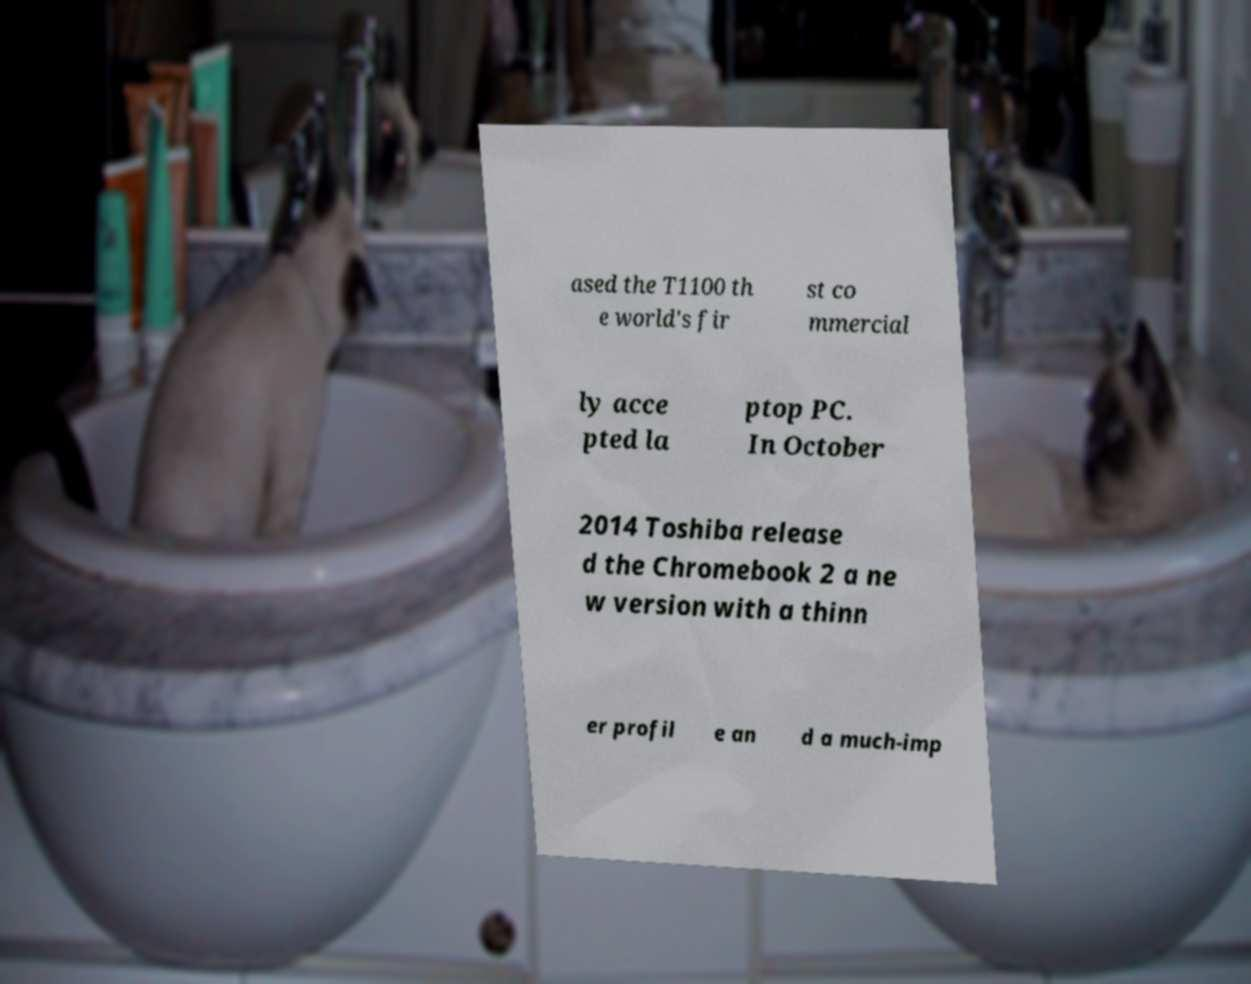Could you assist in decoding the text presented in this image and type it out clearly? ased the T1100 th e world's fir st co mmercial ly acce pted la ptop PC. In October 2014 Toshiba release d the Chromebook 2 a ne w version with a thinn er profil e an d a much-imp 